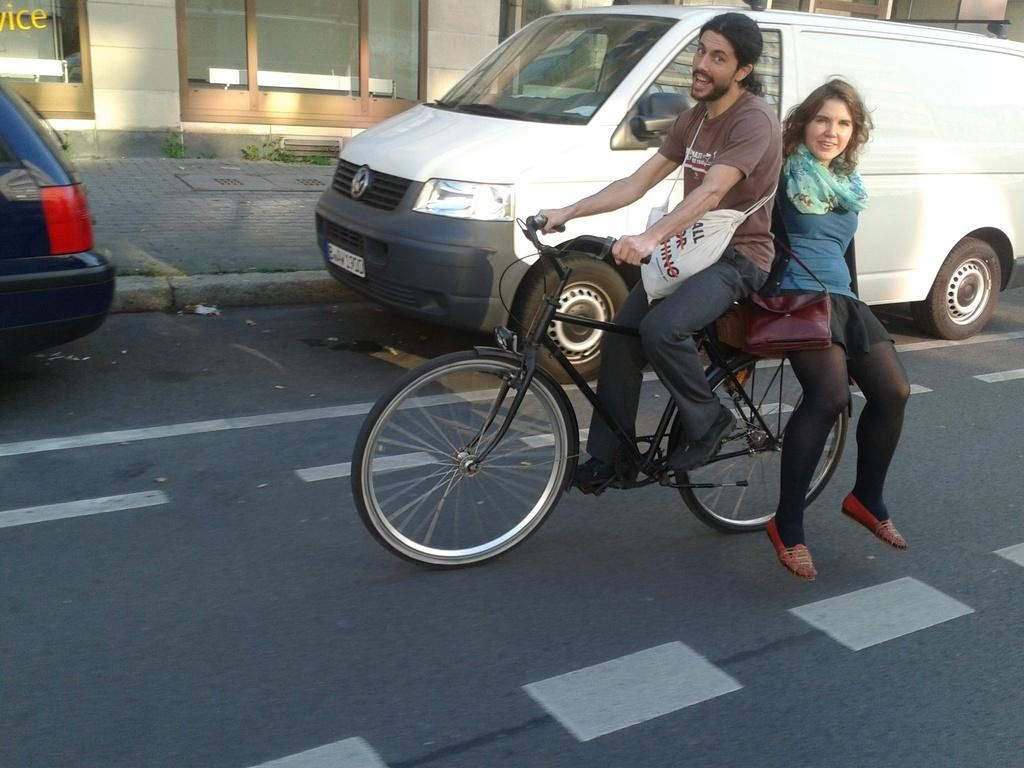How many people are in the image? There are two persons in the image. What are the two persons doing in the image? The two persons are riding a bicycle. What can be seen in the background of the image? There is a car, a building, and grass in the background of the image. What type of songs can be heard coming from the sink in the image? There is no sink or songs present in the image. How many legs does the bicycle have in the image? The bicycle in the image has two wheels, but we cannot determine the number of legs from the image alone. 